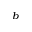<formula> <loc_0><loc_0><loc_500><loc_500>^ { b }</formula> 